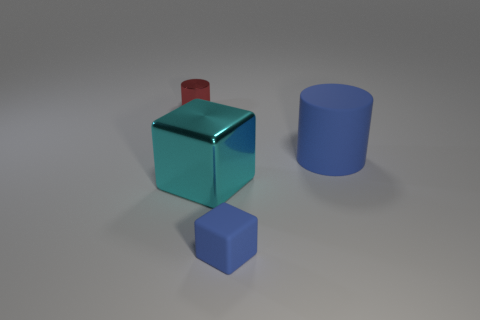Add 4 cyan shiny cubes. How many objects exist? 8 Subtract 0 cyan balls. How many objects are left? 4 Subtract all large matte cylinders. Subtract all cyan blocks. How many objects are left? 2 Add 2 red metal cylinders. How many red metal cylinders are left? 3 Add 4 metal cubes. How many metal cubes exist? 5 